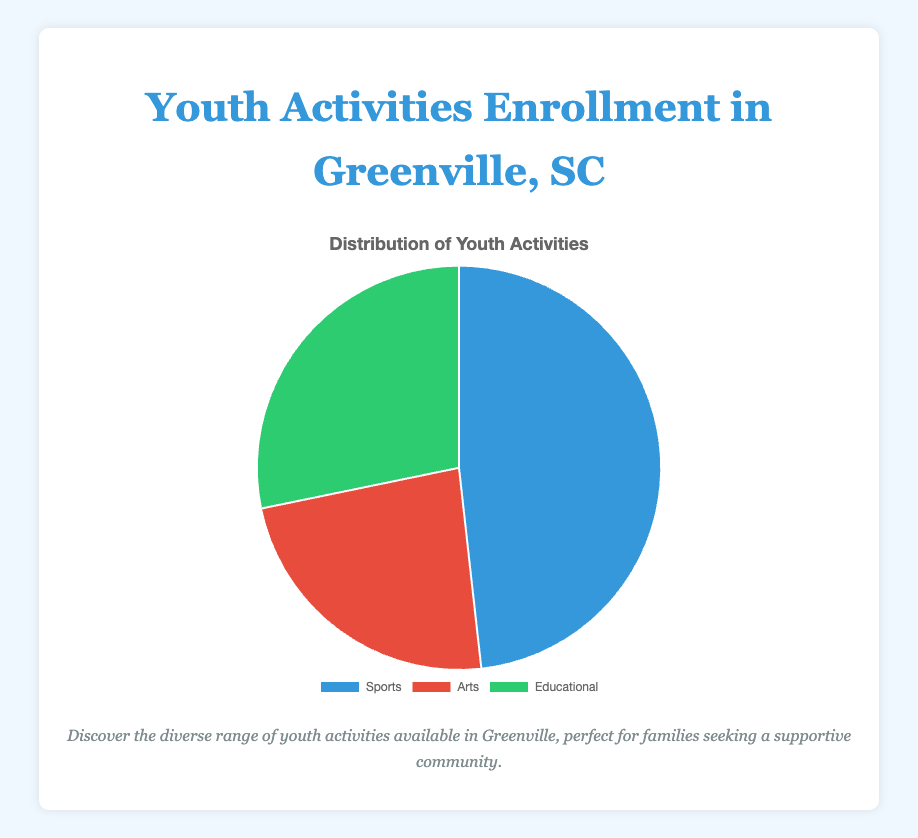Which category has the highest enrollment in youth activities? The chart shows three categories with different section sizes. Sports has the largest section, indicating the highest enrollment.
Answer: Sports How many participants are enrolled in Arts activities? The chart data indicates 1000 participants in Arts activities, represented by the red segment.
Answer: 1000 What is the combined enrollment for Sports and Educational activities? Adding the participants for Sports (2050) and Educational (1200) yields 2050 + 1200 = 3250.
Answer: 3250 Which category has fewer participants, Arts or Educational? Comparing the segments for Arts (1000) and Educational (1200), the red segment (Arts) is smaller.
Answer: Arts What is the percentage of total participants enrolled in Sports activities? Calculating the percentage involves dividing Sports participants (2050) by the total participants (2050 + 1000 + 1200) and multiplying by 100: (2050 / 4250) * 100 ≈ 48.24%.
Answer: 48.24% How much larger is the Sports enrollment compared to Arts enrollment? Subtracting the Arts enrollment (1000) from the Sports enrollment (2050) gives 2050 - 1000 = 1050.
Answer: 1050 What is the difference in enrollment between the category with the highest participation and the category with the lowest participation? Sports has the highest enrollment (2050) and Arts has the lowest (1000), so 2050 - 1000 = 1050.
Answer: 1050 If 200 more participants joined Educational activities, what would be the new total enrollment for Educational? Adding 200 to the current Educational enrollment (1200) results in 1200 + 200 = 1400.
Answer: 1400 